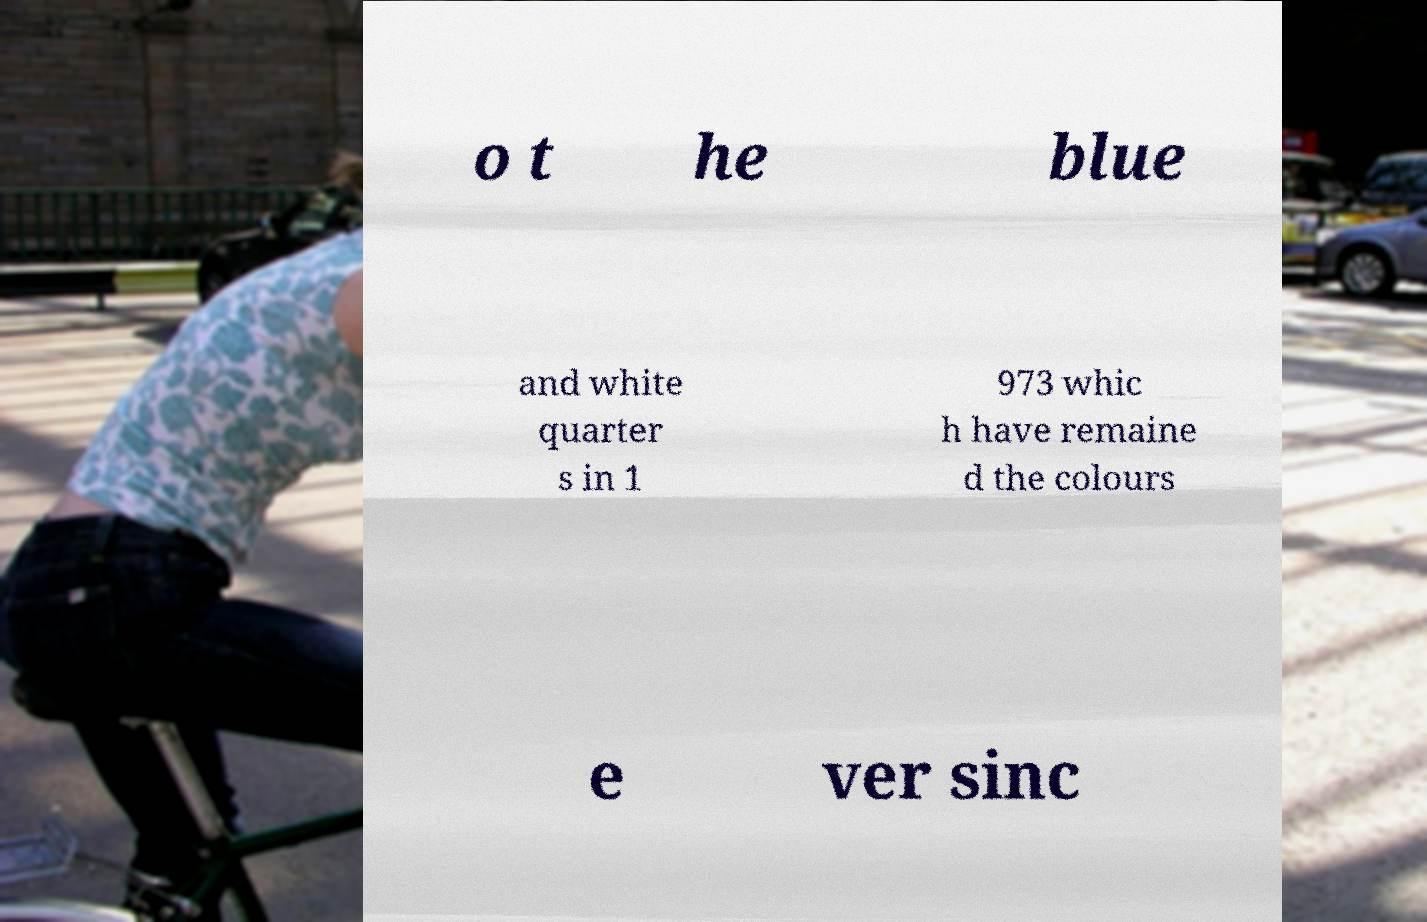Could you assist in decoding the text presented in this image and type it out clearly? o t he blue and white quarter s in 1 973 whic h have remaine d the colours e ver sinc 